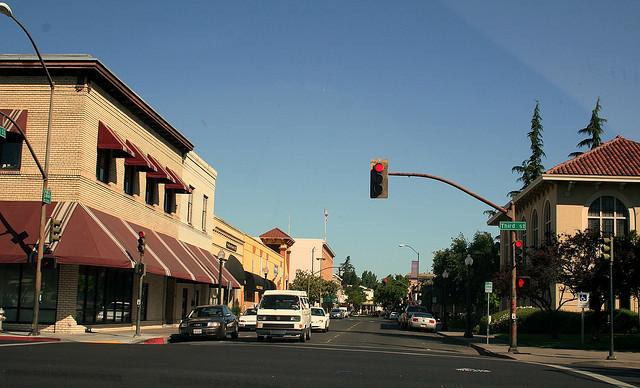From which material is the roofing most visible here sourced? clay 